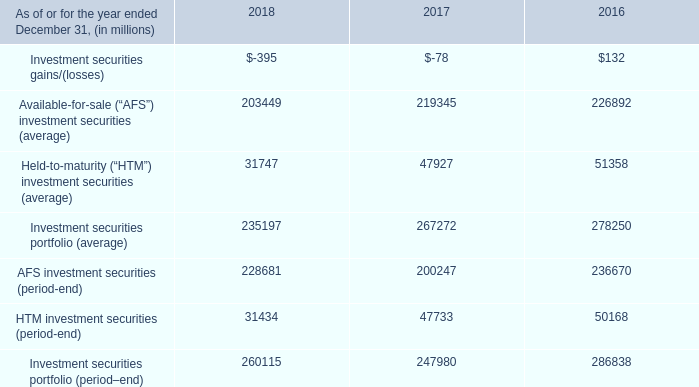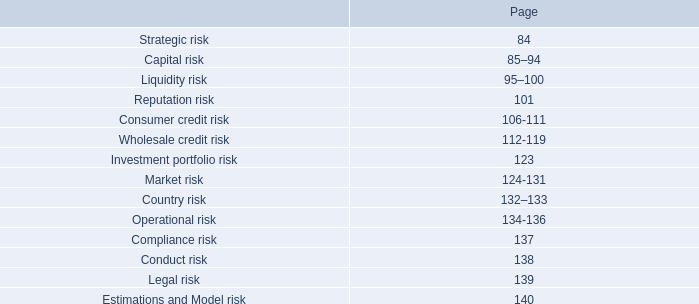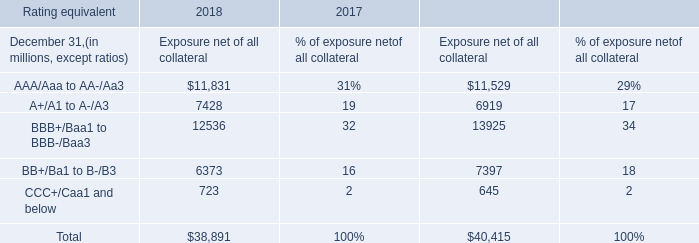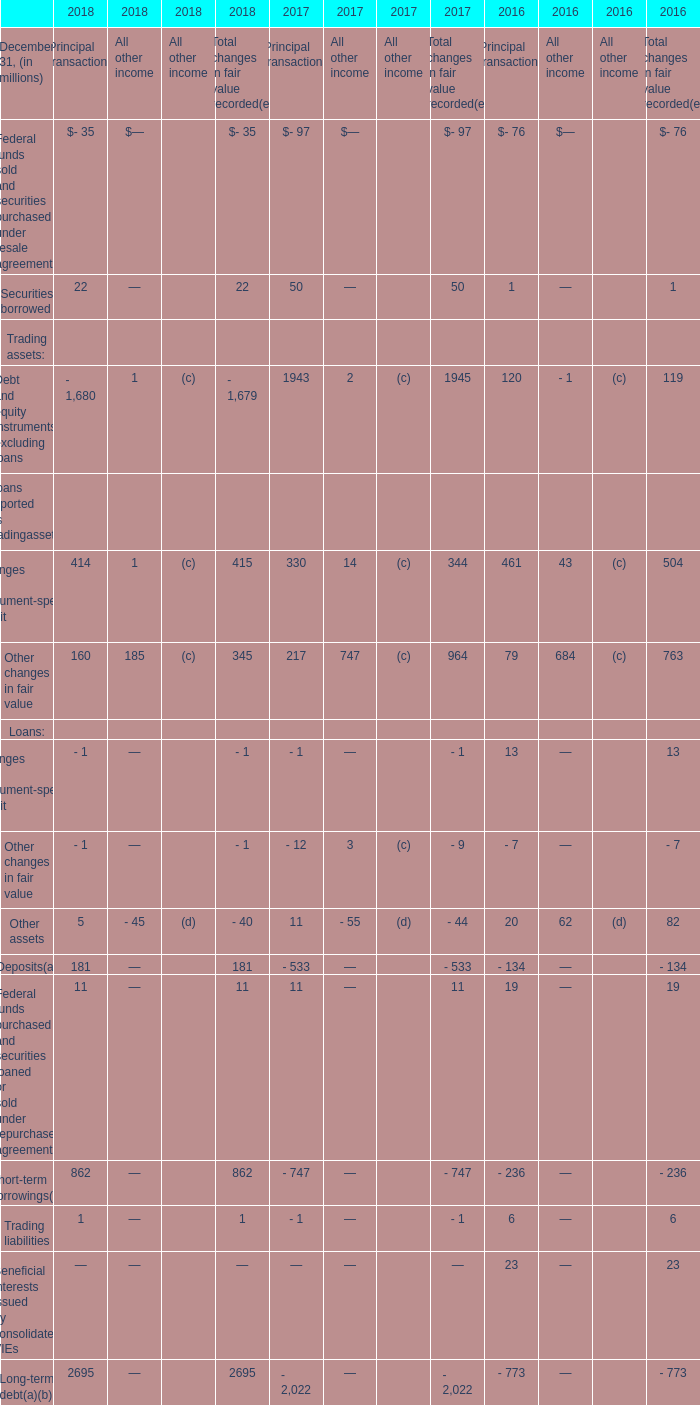what is the estimated percentual decrease observed in the htm investment securities from 2017 to 2018 ? . 
Computations: ((47733 - 31434) / 47733)
Answer: 0.34146. 